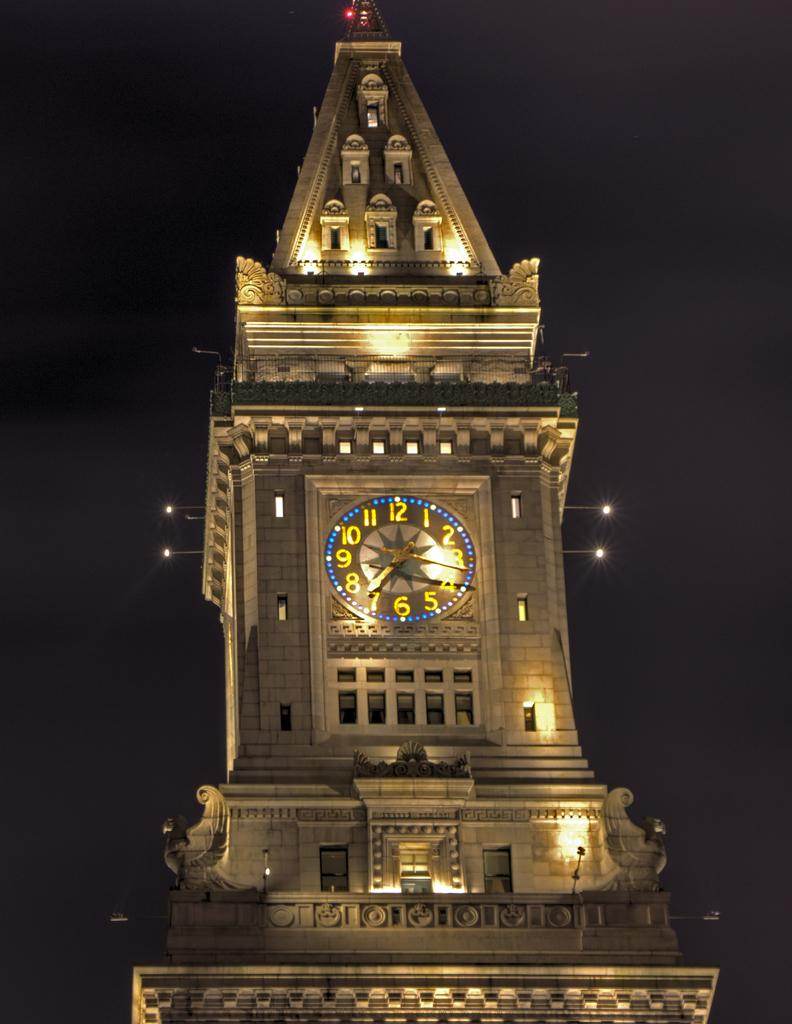What is the main structure in the image? There is a tower in the image. What feature does the tower have? The tower has a clock. Are there any additional elements on the tower? Yes, there are lights on the tower. What is the degree of the argument between the two nations depicted in the image? There are no nations or arguments depicted in the image; it only features a tower with a clock and lights. 